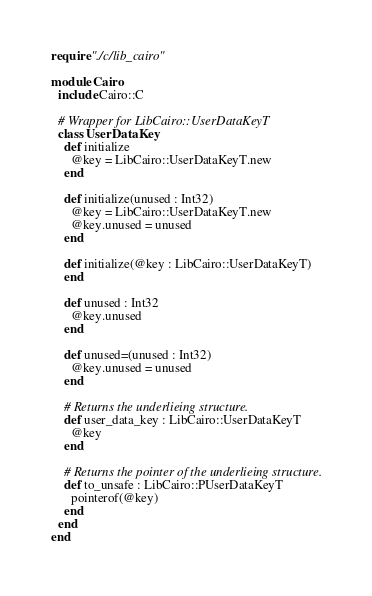<code> <loc_0><loc_0><loc_500><loc_500><_Crystal_>require "./c/lib_cairo"

module Cairo
  include Cairo::C

  # Wrapper for LibCairo::UserDataKeyT
  class UserDataKey
    def initialize
      @key = LibCairo::UserDataKeyT.new
    end

    def initialize(unused : Int32)
      @key = LibCairo::UserDataKeyT.new
      @key.unused = unused
    end

    def initialize(@key : LibCairo::UserDataKeyT)
    end

    def unused : Int32
      @key.unused
    end

    def unused=(unused : Int32)
      @key.unused = unused
    end

    # Returns the underlieing structure.
    def user_data_key : LibCairo::UserDataKeyT
      @key
    end

    # Returns the pointer of the underlieing structure.
    def to_unsafe : LibCairo::PUserDataKeyT
      pointerof(@key)
    end
  end
end
</code> 